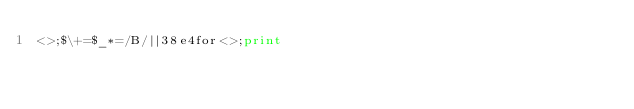Convert code to text. <code><loc_0><loc_0><loc_500><loc_500><_Perl_><>;$\+=$_*=/B/||38e4for<>;print</code> 